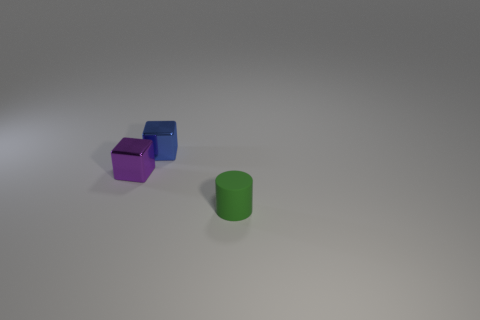How many blue metal things are on the left side of the blue metallic object that is on the right side of the shiny block that is on the left side of the blue metal object?
Your answer should be very brief. 0. There is a purple block that is the same size as the blue thing; what material is it?
Offer a very short reply. Metal. What number of small things are behind the tiny matte cylinder?
Make the answer very short. 2. Are the block that is in front of the blue cube and the tiny thing that is in front of the small purple thing made of the same material?
Keep it short and to the point. No. There is a thing on the right side of the shiny block behind the small metal cube on the left side of the small blue metal object; what is its shape?
Ensure brevity in your answer.  Cylinder. The green matte object is what shape?
Your response must be concise. Cylinder. The green matte object that is the same size as the blue block is what shape?
Your response must be concise. Cylinder. Do the small thing that is behind the purple thing and the shiny thing that is to the left of the blue metallic block have the same shape?
Offer a very short reply. Yes. What number of things are either things that are to the left of the cylinder or green cylinders that are in front of the small blue metallic cube?
Your response must be concise. 3. What number of other things are there of the same material as the cylinder
Your response must be concise. 0. 